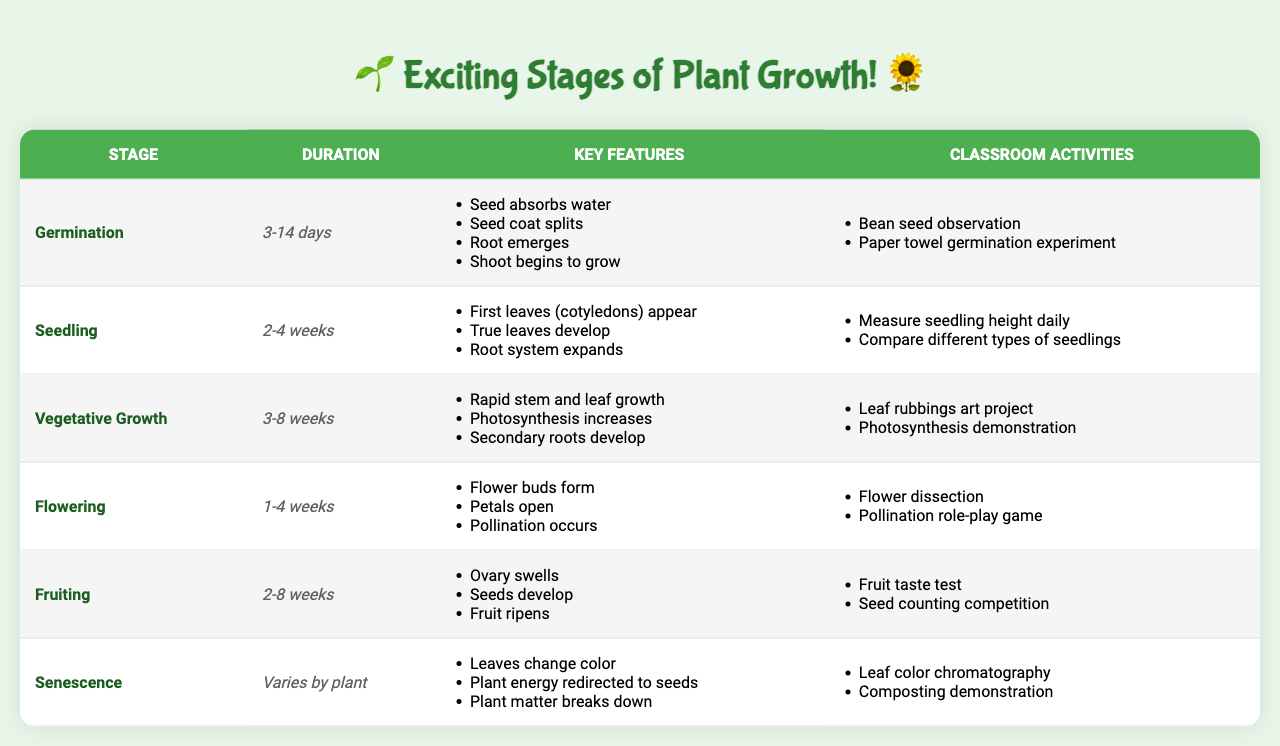What is the duration of the Germination stage? The Germination stage has a specified duration of 3-14 days according to the table.
Answer: 3-14 days Which classroom activity is associated with the Seedling stage? One of the classroom activities listed for the Seedling stage is "Measure seedling height daily."
Answer: Measure seedling height daily How many weeks does the Flowering stage last at most? The maximum duration of the Flowering stage is 4 weeks as indicated in the table.
Answer: 4 weeks Does the Fruiting stage involve seed development? Yes, the Fruiting stage includes a key feature stating that seeds develop during this time.
Answer: Yes What are the key features of the Vegetative Growth stage? The key features include rapid stem and leaf growth, increased photosynthesis, and development of secondary roots. Collectively, these features help understand the growth process.
Answer: Rapid stem and leaf growth, increased photosynthesis, development of secondary roots Which stage has the longest potential duration? The Fruiting stage can last up to 8 weeks, which is the longest duration compared to other stages.
Answer: Fruiting How many stages of plant growth are listed in the table? There are 6 stages of plant growth outlined in the table, which is calculated by counting the entries.
Answer: 6 stages What is the average duration of the Germination and Seedling stages? The Germination stage lasts between 3-14 days, and the Seedling stage lasts 2-4 weeks (14 days). The average therefore is computed by converting the ranges into a single period (e.g., average of 3-14 days is 8.5 days and 2-4 weeks is 21 days), leading to a total average of around 14.75 days for both stages combined.
Answer: Approximately 14.75 days Which stage has classroom activities related to composting? The Senescence stage has "Composting demonstration" listed as one of its classroom activities. This ties in composting with the process of decay and natural cycles.
Answer: Senescence In which stage can you observe leaf color changes? Leaf color changes are observed during the Senescence stage, as mentioned in its key features.
Answer: Senescence What stage occurs after the Seedling stage? The stage that follows the Seedling stage is the Vegetative Growth stage, as per the order listed in the table.
Answer: Vegetative Growth What is a common activity for the Flowering stage? A common activity for the Flowering stage includes "Flower dissection," allowing students to explore plant anatomy during that growth phase.
Answer: Flower dissection What are the two classroom activities associated with the Germination stage? The Germination stage includes two classroom activities: "Bean seed observation" and "Paper towel germination experiment." These activities provide hands-on learning experiences about germination.
Answer: Bean seed observation, Paper towel germination experiment 